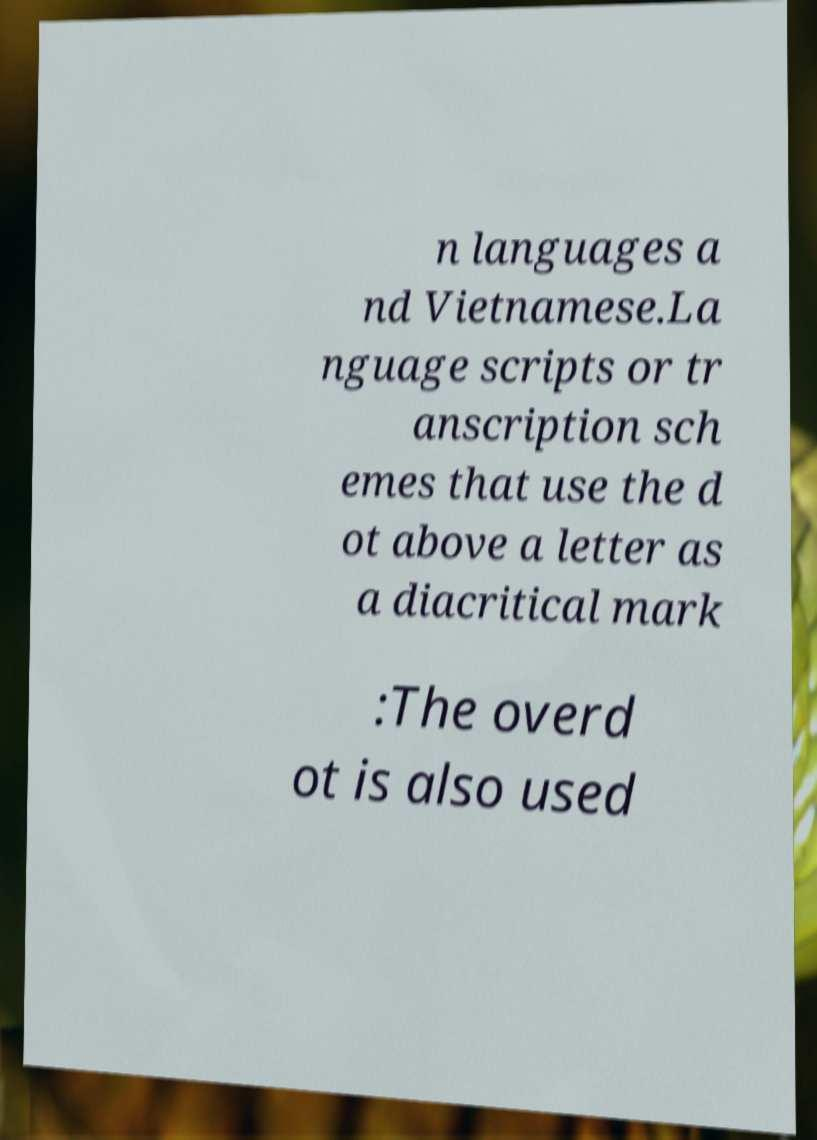Please identify and transcribe the text found in this image. n languages a nd Vietnamese.La nguage scripts or tr anscription sch emes that use the d ot above a letter as a diacritical mark :The overd ot is also used 